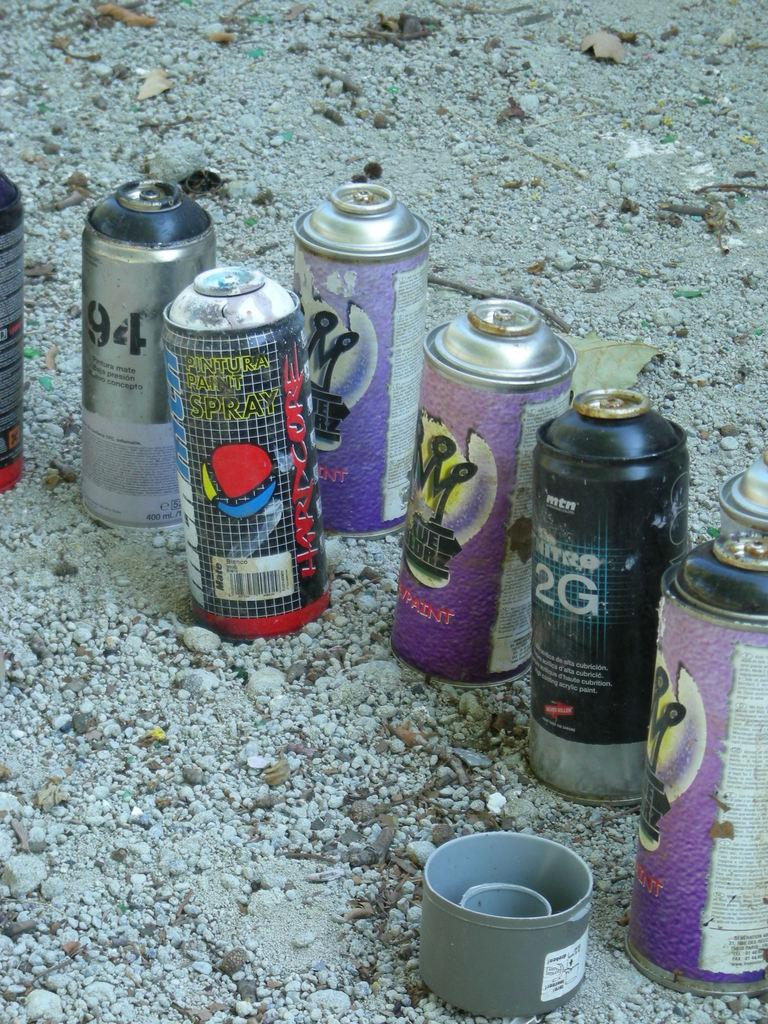<image>
Provide a brief description of the given image. Several bottles of open spray paint sit in the gravel, including paint called Hardcore. 